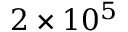<formula> <loc_0><loc_0><loc_500><loc_500>2 \times 1 0 ^ { 5 }</formula> 